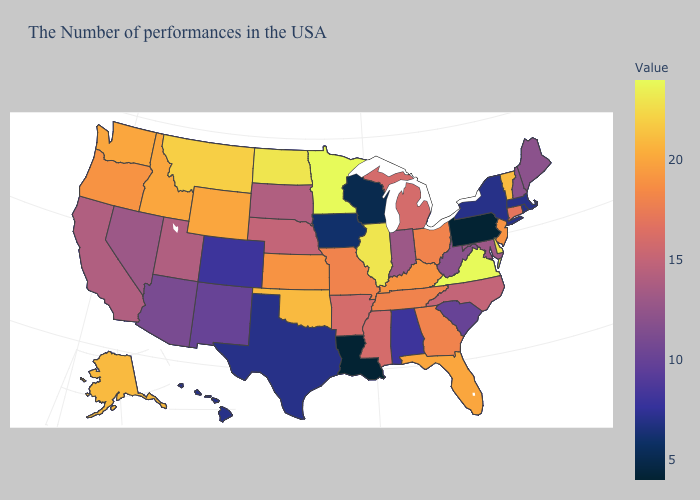Which states have the lowest value in the West?
Answer briefly. Hawaii. Which states have the highest value in the USA?
Give a very brief answer. Virginia, Minnesota. Which states have the lowest value in the USA?
Be succinct. Pennsylvania, Louisiana. Which states have the lowest value in the South?
Concise answer only. Louisiana. Does Montana have the highest value in the West?
Answer briefly. Yes. Among the states that border Oklahoma , does Texas have the lowest value?
Give a very brief answer. Yes. Does Virginia have the highest value in the USA?
Answer briefly. Yes. Among the states that border Maryland , does Virginia have the lowest value?
Be succinct. No. 